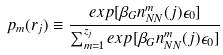<formula> <loc_0><loc_0><loc_500><loc_500>p _ { m } ( { r } _ { j } ) \equiv \frac { e x p [ \beta _ { G } n _ { N N } ^ { m } ( j ) \epsilon _ { 0 } ] } { \sum _ { m = 1 } ^ { z _ { j } } e x p [ \beta _ { G } n _ { N N } ^ { m } ( j ) \epsilon _ { 0 } ] }</formula> 